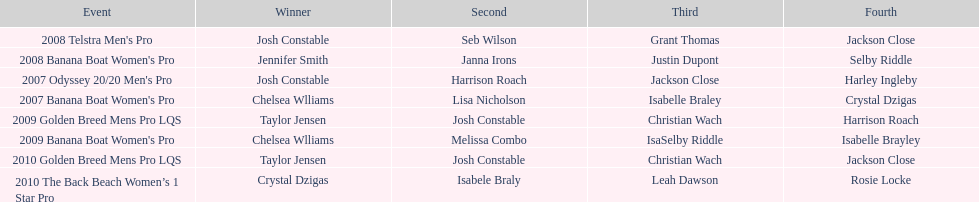How many times was josh constable second? 2. 